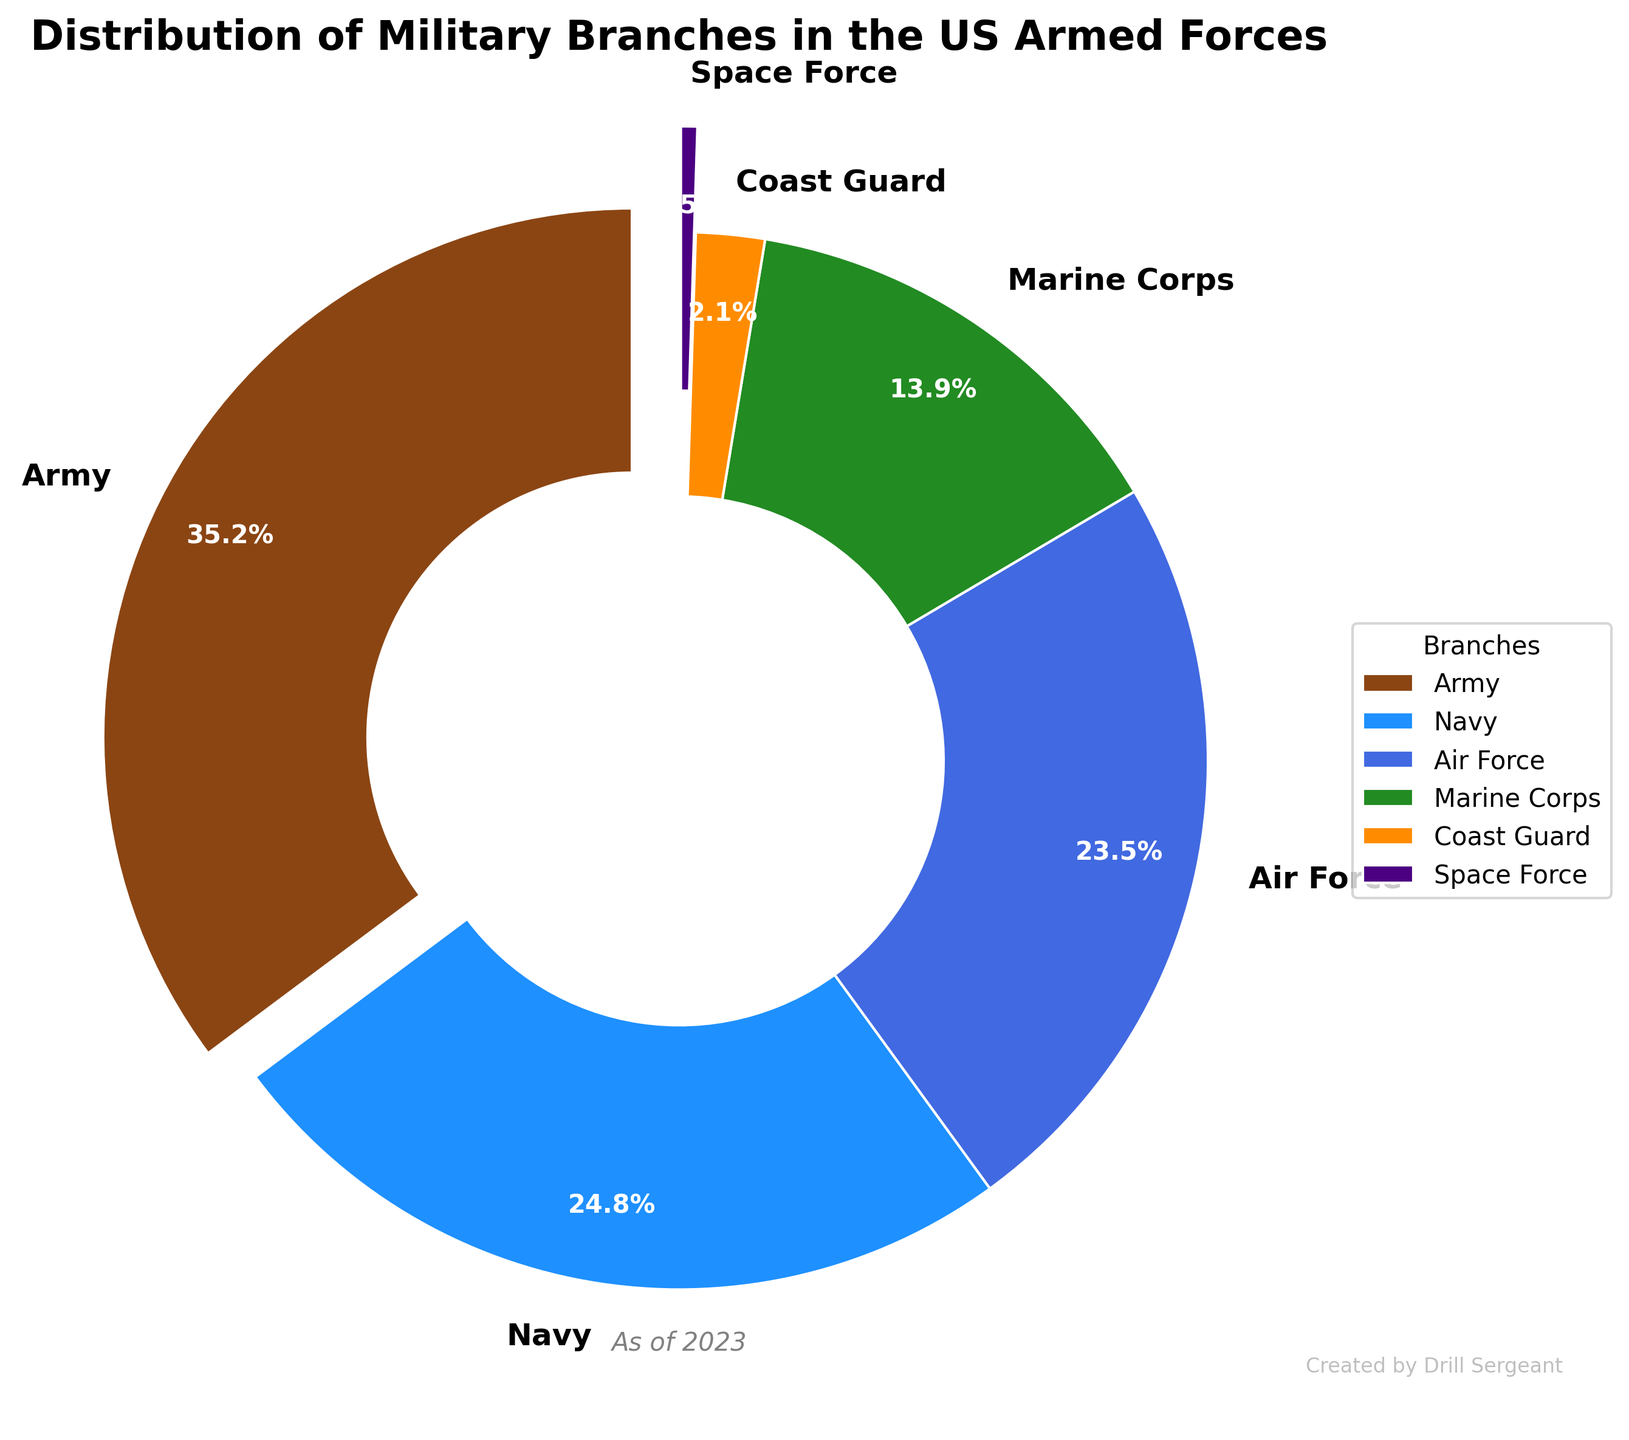Which branch has the highest percentage in the distribution? The figure shows different branches with their corresponding percentages. The branch with the highest percentage has the largest segment in the pie chart. The Army has the largest segment with 35.2%.
Answer: Army Which two branches together make up more than half of the total distribution? Identify the percentages of all branches and sum combinations to find if they exceed 50%. The Army (35.2%) and Navy (24.8%) together sum up to 60%, which is more than half of the total distribution.
Answer: Army and Navy How much larger is the Air Force percentage compared to the Space Force percentage? Subtract the percentage of the Space Force from the percentage of the Air Force. Air Force has 23.5% and Space Force has 0.5%, so the difference is 23.5% - 0.5% = 23%.
Answer: 23% What is the combined percentage of the Marine Corps and the Coast Guard? Sum the percentages of Marine Corps and Coast Guard. Marine Corps is 13.9% and Coast Guard is 2.1%. 13.9% + 2.1% = 16%.
Answer: 16% Which branch is represented by the lightest color in the pie chart? Visually identify the segments and their corresponding colors. Colors typically represent the branches, and the lightest color segment represents School XYZ. In the figure, the Space Force segment is the lightest.
Answer: Space Force Is the percentage of the Navy greater than 20% and less than 30%? Check the percentage value for the Navy. The figure shows 24.8% for the Navy, which satisfies both conditions of being greater than 20% and less than 30%.
Answer: Yes What percentage of the total distribution do all branches other than the Army contribute? Subtract the Army's percentage from 100% to find the contribution of all other branches. Non-Army contributions are 100% - 35.2% = 64.8%.
Answer: 64.8% Are there any branches with less than 10% representation? Visually inspect the pie chart for segments representing less than 10%. The Coast Guard (2.1%) and Space Force (0.5%) both have less than 10% representation.
Answer: Yes Which two branches together account for nearly half the total distribution? Identify which branches' percentages sum closest to 50%. The Navy (24.8%) and Air Force (23.5%) together sum up to 48.3%, which is close to 50%.
Answer: Navy and Air Force 